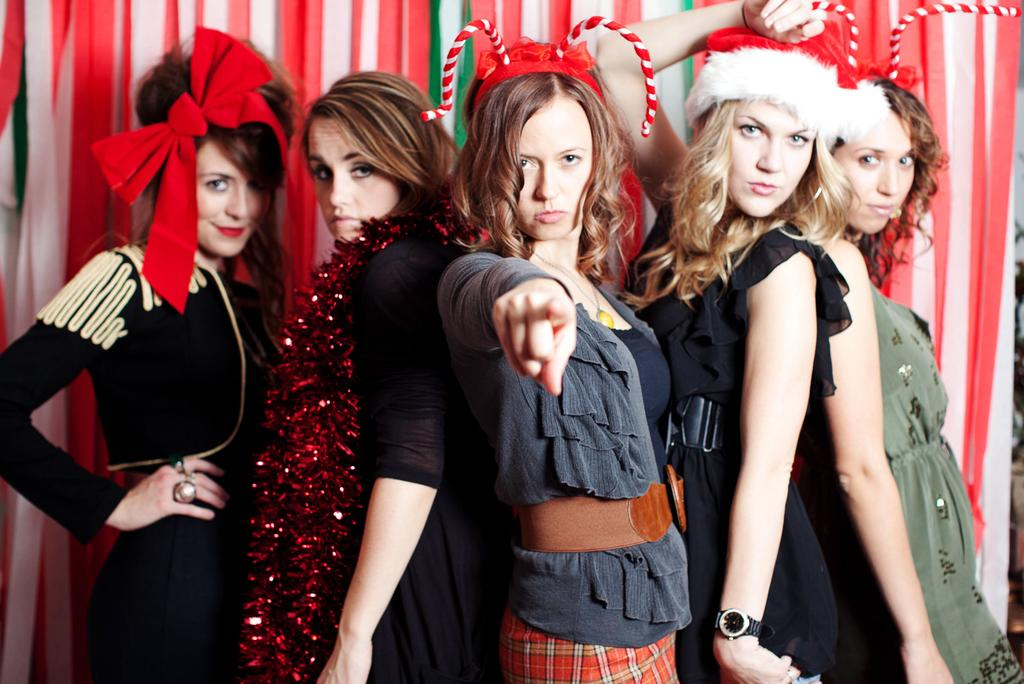What is happening in the foreground of the image? There is a group of people standing in the front of the image. What can be seen in the background of the image? There is a curtain and a wall in the background of the image. What type of riddle is being solved by the group of people in the image? There is no riddle being solved in the image; it simply shows a group of people standing in the front. Can you describe the action of the kettle in the image? There is no kettle present in the image. 